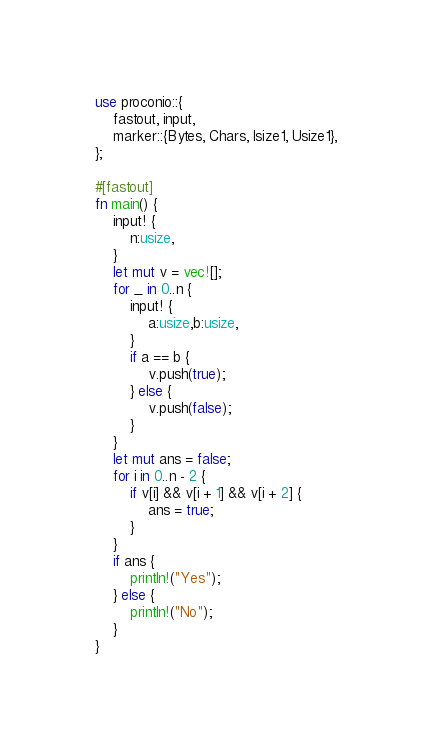<code> <loc_0><loc_0><loc_500><loc_500><_Rust_>use proconio::{
    fastout, input,
    marker::{Bytes, Chars, Isize1, Usize1},
};

#[fastout]
fn main() {
    input! {
        n:usize,
    }
    let mut v = vec![];
    for _ in 0..n {
        input! {
            a:usize,b:usize,
        }
        if a == b {
            v.push(true);
        } else {
            v.push(false);
        }
    }
    let mut ans = false;
    for i in 0..n - 2 {
        if v[i] && v[i + 1] && v[i + 2] {
            ans = true;
        }
    }
    if ans {
        println!("Yes");
    } else {
        println!("No");
    }
}
</code> 